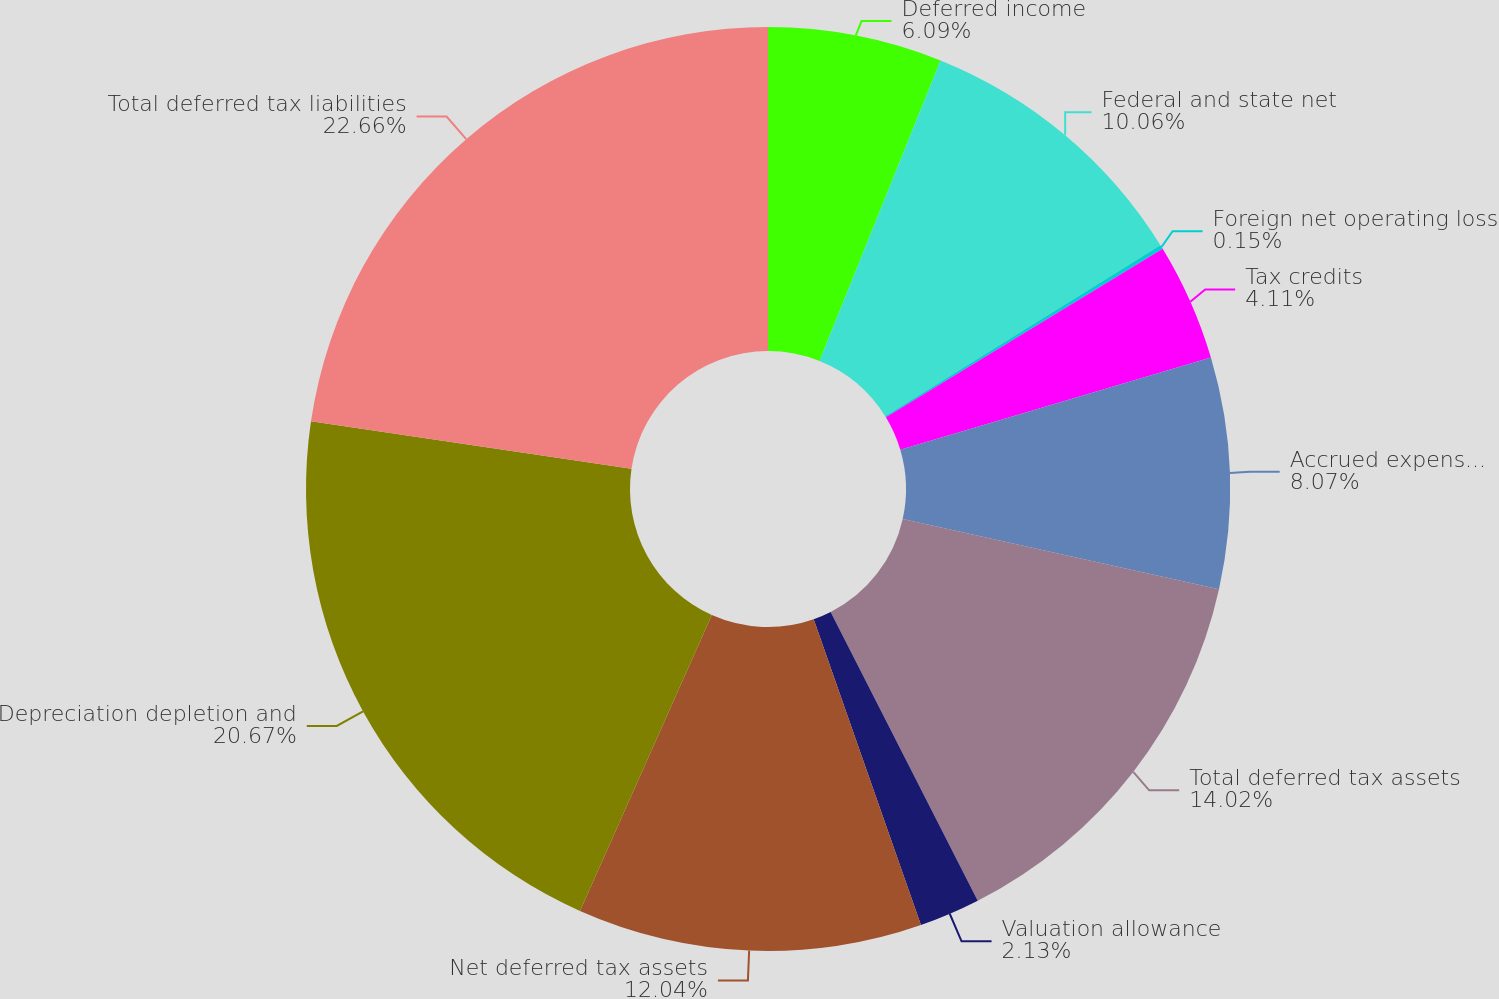Convert chart to OTSL. <chart><loc_0><loc_0><loc_500><loc_500><pie_chart><fcel>Deferred income<fcel>Federal and state net<fcel>Foreign net operating loss<fcel>Tax credits<fcel>Accrued expenses and<fcel>Total deferred tax assets<fcel>Valuation allowance<fcel>Net deferred tax assets<fcel>Depreciation depletion and<fcel>Total deferred tax liabilities<nl><fcel>6.09%<fcel>10.06%<fcel>0.15%<fcel>4.11%<fcel>8.07%<fcel>14.02%<fcel>2.13%<fcel>12.04%<fcel>20.67%<fcel>22.66%<nl></chart> 